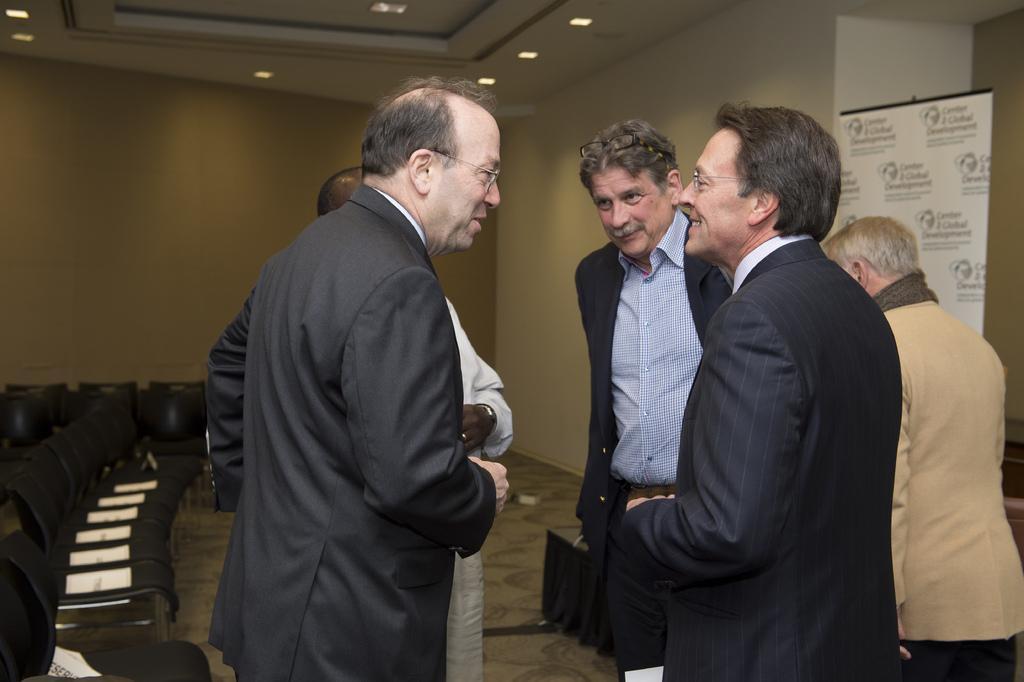Can you describe this image briefly? In this image in the middle, there is a man, he wears a suit, in front of him there is a man, he wears a suit, shirt, he is smiling. In the middle there is a man, he wears a suit, shirt, trouser. On the right there is a man, he wears a suit, trouser. On the left there is a ,man. In the middle there are chairs, posters, text, tablecloth, floor, wall and lights. 